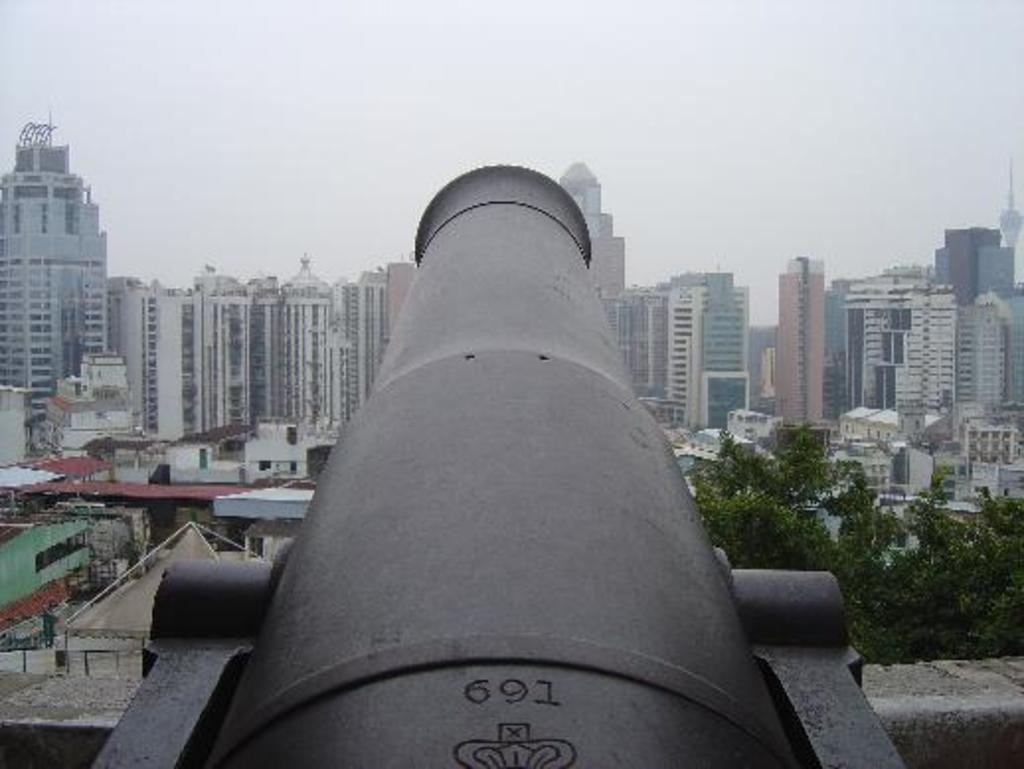What is the main object in the front of the image? There is a cannon in the front of the image. What can be seen in the distance behind the cannon? There are buildings and trees in the background of the image. How would you describe the sky in the image? The sky is cloudy in the image. What type of floor can be seen in the image? There is no floor visible in the image; it is an outdoor scene with a cannon, buildings, trees, and a cloudy sky. 